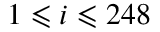Convert formula to latex. <formula><loc_0><loc_0><loc_500><loc_500>1 \leqslant i \leqslant 2 4 8</formula> 